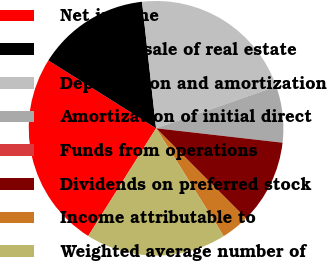Convert chart. <chart><loc_0><loc_0><loc_500><loc_500><pie_chart><fcel>Net income<fcel>(Gain) on sale of real estate<fcel>Depreciation and amortization<fcel>Amortization of initial direct<fcel>Funds from operations<fcel>Dividends on preferred stock<fcel>Income attributable to<fcel>Weighted average number of<nl><fcel>25.0%<fcel>14.29%<fcel>21.43%<fcel>7.14%<fcel>0.0%<fcel>10.71%<fcel>3.57%<fcel>17.86%<nl></chart> 